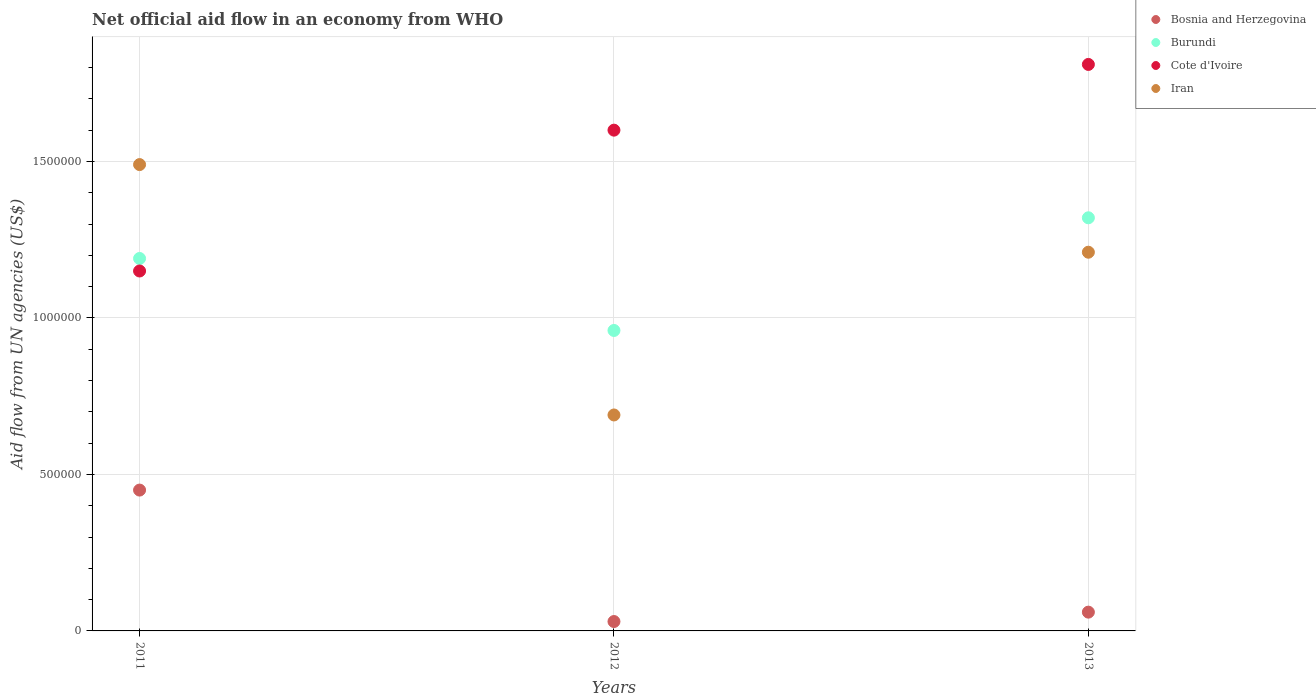Is the number of dotlines equal to the number of legend labels?
Your answer should be very brief. Yes. What is the net official aid flow in Bosnia and Herzegovina in 2012?
Ensure brevity in your answer.  3.00e+04. Across all years, what is the minimum net official aid flow in Cote d'Ivoire?
Provide a succinct answer. 1.15e+06. In which year was the net official aid flow in Burundi maximum?
Give a very brief answer. 2013. In which year was the net official aid flow in Cote d'Ivoire minimum?
Offer a very short reply. 2011. What is the total net official aid flow in Bosnia and Herzegovina in the graph?
Your response must be concise. 5.40e+05. What is the difference between the net official aid flow in Burundi in 2011 and that in 2013?
Offer a very short reply. -1.30e+05. What is the difference between the net official aid flow in Burundi in 2013 and the net official aid flow in Iran in 2012?
Provide a succinct answer. 6.30e+05. What is the average net official aid flow in Burundi per year?
Provide a short and direct response. 1.16e+06. In how many years, is the net official aid flow in Bosnia and Herzegovina greater than 1000000 US$?
Your response must be concise. 0. What is the ratio of the net official aid flow in Burundi in 2011 to that in 2013?
Your response must be concise. 0.9. Is the net official aid flow in Bosnia and Herzegovina in 2011 less than that in 2012?
Keep it short and to the point. No. Is the difference between the net official aid flow in Iran in 2011 and 2012 greater than the difference between the net official aid flow in Burundi in 2011 and 2012?
Your answer should be very brief. Yes. What is the difference between the highest and the second highest net official aid flow in Cote d'Ivoire?
Provide a succinct answer. 2.10e+05. What is the difference between the highest and the lowest net official aid flow in Bosnia and Herzegovina?
Offer a terse response. 4.20e+05. Is it the case that in every year, the sum of the net official aid flow in Burundi and net official aid flow in Cote d'Ivoire  is greater than the net official aid flow in Iran?
Your answer should be compact. Yes. How many years are there in the graph?
Keep it short and to the point. 3. Does the graph contain grids?
Make the answer very short. Yes. What is the title of the graph?
Provide a short and direct response. Net official aid flow in an economy from WHO. What is the label or title of the Y-axis?
Provide a succinct answer. Aid flow from UN agencies (US$). What is the Aid flow from UN agencies (US$) of Burundi in 2011?
Provide a succinct answer. 1.19e+06. What is the Aid flow from UN agencies (US$) in Cote d'Ivoire in 2011?
Provide a short and direct response. 1.15e+06. What is the Aid flow from UN agencies (US$) of Iran in 2011?
Your response must be concise. 1.49e+06. What is the Aid flow from UN agencies (US$) in Burundi in 2012?
Offer a very short reply. 9.60e+05. What is the Aid flow from UN agencies (US$) in Cote d'Ivoire in 2012?
Your answer should be very brief. 1.60e+06. What is the Aid flow from UN agencies (US$) in Iran in 2012?
Offer a very short reply. 6.90e+05. What is the Aid flow from UN agencies (US$) in Burundi in 2013?
Your answer should be very brief. 1.32e+06. What is the Aid flow from UN agencies (US$) of Cote d'Ivoire in 2013?
Your response must be concise. 1.81e+06. What is the Aid flow from UN agencies (US$) of Iran in 2013?
Ensure brevity in your answer.  1.21e+06. Across all years, what is the maximum Aid flow from UN agencies (US$) of Burundi?
Keep it short and to the point. 1.32e+06. Across all years, what is the maximum Aid flow from UN agencies (US$) of Cote d'Ivoire?
Your answer should be compact. 1.81e+06. Across all years, what is the maximum Aid flow from UN agencies (US$) of Iran?
Provide a succinct answer. 1.49e+06. Across all years, what is the minimum Aid flow from UN agencies (US$) in Bosnia and Herzegovina?
Offer a terse response. 3.00e+04. Across all years, what is the minimum Aid flow from UN agencies (US$) of Burundi?
Your answer should be compact. 9.60e+05. Across all years, what is the minimum Aid flow from UN agencies (US$) in Cote d'Ivoire?
Your answer should be compact. 1.15e+06. Across all years, what is the minimum Aid flow from UN agencies (US$) in Iran?
Your response must be concise. 6.90e+05. What is the total Aid flow from UN agencies (US$) of Bosnia and Herzegovina in the graph?
Make the answer very short. 5.40e+05. What is the total Aid flow from UN agencies (US$) of Burundi in the graph?
Your answer should be very brief. 3.47e+06. What is the total Aid flow from UN agencies (US$) of Cote d'Ivoire in the graph?
Ensure brevity in your answer.  4.56e+06. What is the total Aid flow from UN agencies (US$) of Iran in the graph?
Your answer should be compact. 3.39e+06. What is the difference between the Aid flow from UN agencies (US$) of Bosnia and Herzegovina in 2011 and that in 2012?
Your answer should be very brief. 4.20e+05. What is the difference between the Aid flow from UN agencies (US$) in Cote d'Ivoire in 2011 and that in 2012?
Provide a succinct answer. -4.50e+05. What is the difference between the Aid flow from UN agencies (US$) of Bosnia and Herzegovina in 2011 and that in 2013?
Keep it short and to the point. 3.90e+05. What is the difference between the Aid flow from UN agencies (US$) of Cote d'Ivoire in 2011 and that in 2013?
Offer a very short reply. -6.60e+05. What is the difference between the Aid flow from UN agencies (US$) of Bosnia and Herzegovina in 2012 and that in 2013?
Your answer should be very brief. -3.00e+04. What is the difference between the Aid flow from UN agencies (US$) in Burundi in 2012 and that in 2013?
Your response must be concise. -3.60e+05. What is the difference between the Aid flow from UN agencies (US$) of Cote d'Ivoire in 2012 and that in 2013?
Give a very brief answer. -2.10e+05. What is the difference between the Aid flow from UN agencies (US$) in Iran in 2012 and that in 2013?
Keep it short and to the point. -5.20e+05. What is the difference between the Aid flow from UN agencies (US$) of Bosnia and Herzegovina in 2011 and the Aid flow from UN agencies (US$) of Burundi in 2012?
Offer a terse response. -5.10e+05. What is the difference between the Aid flow from UN agencies (US$) of Bosnia and Herzegovina in 2011 and the Aid flow from UN agencies (US$) of Cote d'Ivoire in 2012?
Your response must be concise. -1.15e+06. What is the difference between the Aid flow from UN agencies (US$) of Bosnia and Herzegovina in 2011 and the Aid flow from UN agencies (US$) of Iran in 2012?
Your response must be concise. -2.40e+05. What is the difference between the Aid flow from UN agencies (US$) in Burundi in 2011 and the Aid flow from UN agencies (US$) in Cote d'Ivoire in 2012?
Provide a short and direct response. -4.10e+05. What is the difference between the Aid flow from UN agencies (US$) of Burundi in 2011 and the Aid flow from UN agencies (US$) of Iran in 2012?
Give a very brief answer. 5.00e+05. What is the difference between the Aid flow from UN agencies (US$) in Bosnia and Herzegovina in 2011 and the Aid flow from UN agencies (US$) in Burundi in 2013?
Make the answer very short. -8.70e+05. What is the difference between the Aid flow from UN agencies (US$) of Bosnia and Herzegovina in 2011 and the Aid flow from UN agencies (US$) of Cote d'Ivoire in 2013?
Offer a very short reply. -1.36e+06. What is the difference between the Aid flow from UN agencies (US$) in Bosnia and Herzegovina in 2011 and the Aid flow from UN agencies (US$) in Iran in 2013?
Make the answer very short. -7.60e+05. What is the difference between the Aid flow from UN agencies (US$) in Burundi in 2011 and the Aid flow from UN agencies (US$) in Cote d'Ivoire in 2013?
Your answer should be very brief. -6.20e+05. What is the difference between the Aid flow from UN agencies (US$) of Cote d'Ivoire in 2011 and the Aid flow from UN agencies (US$) of Iran in 2013?
Your answer should be compact. -6.00e+04. What is the difference between the Aid flow from UN agencies (US$) in Bosnia and Herzegovina in 2012 and the Aid flow from UN agencies (US$) in Burundi in 2013?
Give a very brief answer. -1.29e+06. What is the difference between the Aid flow from UN agencies (US$) of Bosnia and Herzegovina in 2012 and the Aid flow from UN agencies (US$) of Cote d'Ivoire in 2013?
Your response must be concise. -1.78e+06. What is the difference between the Aid flow from UN agencies (US$) of Bosnia and Herzegovina in 2012 and the Aid flow from UN agencies (US$) of Iran in 2013?
Give a very brief answer. -1.18e+06. What is the difference between the Aid flow from UN agencies (US$) of Burundi in 2012 and the Aid flow from UN agencies (US$) of Cote d'Ivoire in 2013?
Your answer should be very brief. -8.50e+05. What is the difference between the Aid flow from UN agencies (US$) in Cote d'Ivoire in 2012 and the Aid flow from UN agencies (US$) in Iran in 2013?
Give a very brief answer. 3.90e+05. What is the average Aid flow from UN agencies (US$) of Bosnia and Herzegovina per year?
Make the answer very short. 1.80e+05. What is the average Aid flow from UN agencies (US$) of Burundi per year?
Provide a short and direct response. 1.16e+06. What is the average Aid flow from UN agencies (US$) of Cote d'Ivoire per year?
Provide a succinct answer. 1.52e+06. What is the average Aid flow from UN agencies (US$) in Iran per year?
Offer a terse response. 1.13e+06. In the year 2011, what is the difference between the Aid flow from UN agencies (US$) in Bosnia and Herzegovina and Aid flow from UN agencies (US$) in Burundi?
Provide a succinct answer. -7.40e+05. In the year 2011, what is the difference between the Aid flow from UN agencies (US$) of Bosnia and Herzegovina and Aid flow from UN agencies (US$) of Cote d'Ivoire?
Keep it short and to the point. -7.00e+05. In the year 2011, what is the difference between the Aid flow from UN agencies (US$) of Bosnia and Herzegovina and Aid flow from UN agencies (US$) of Iran?
Offer a terse response. -1.04e+06. In the year 2011, what is the difference between the Aid flow from UN agencies (US$) in Burundi and Aid flow from UN agencies (US$) in Cote d'Ivoire?
Your answer should be very brief. 4.00e+04. In the year 2012, what is the difference between the Aid flow from UN agencies (US$) in Bosnia and Herzegovina and Aid flow from UN agencies (US$) in Burundi?
Offer a terse response. -9.30e+05. In the year 2012, what is the difference between the Aid flow from UN agencies (US$) in Bosnia and Herzegovina and Aid flow from UN agencies (US$) in Cote d'Ivoire?
Offer a terse response. -1.57e+06. In the year 2012, what is the difference between the Aid flow from UN agencies (US$) of Bosnia and Herzegovina and Aid flow from UN agencies (US$) of Iran?
Your answer should be compact. -6.60e+05. In the year 2012, what is the difference between the Aid flow from UN agencies (US$) of Burundi and Aid flow from UN agencies (US$) of Cote d'Ivoire?
Provide a short and direct response. -6.40e+05. In the year 2012, what is the difference between the Aid flow from UN agencies (US$) of Cote d'Ivoire and Aid flow from UN agencies (US$) of Iran?
Ensure brevity in your answer.  9.10e+05. In the year 2013, what is the difference between the Aid flow from UN agencies (US$) of Bosnia and Herzegovina and Aid flow from UN agencies (US$) of Burundi?
Keep it short and to the point. -1.26e+06. In the year 2013, what is the difference between the Aid flow from UN agencies (US$) in Bosnia and Herzegovina and Aid flow from UN agencies (US$) in Cote d'Ivoire?
Ensure brevity in your answer.  -1.75e+06. In the year 2013, what is the difference between the Aid flow from UN agencies (US$) in Bosnia and Herzegovina and Aid flow from UN agencies (US$) in Iran?
Your answer should be compact. -1.15e+06. In the year 2013, what is the difference between the Aid flow from UN agencies (US$) in Burundi and Aid flow from UN agencies (US$) in Cote d'Ivoire?
Offer a terse response. -4.90e+05. In the year 2013, what is the difference between the Aid flow from UN agencies (US$) in Burundi and Aid flow from UN agencies (US$) in Iran?
Provide a succinct answer. 1.10e+05. What is the ratio of the Aid flow from UN agencies (US$) of Bosnia and Herzegovina in 2011 to that in 2012?
Your answer should be very brief. 15. What is the ratio of the Aid flow from UN agencies (US$) of Burundi in 2011 to that in 2012?
Provide a succinct answer. 1.24. What is the ratio of the Aid flow from UN agencies (US$) in Cote d'Ivoire in 2011 to that in 2012?
Keep it short and to the point. 0.72. What is the ratio of the Aid flow from UN agencies (US$) in Iran in 2011 to that in 2012?
Make the answer very short. 2.16. What is the ratio of the Aid flow from UN agencies (US$) in Burundi in 2011 to that in 2013?
Offer a terse response. 0.9. What is the ratio of the Aid flow from UN agencies (US$) of Cote d'Ivoire in 2011 to that in 2013?
Provide a short and direct response. 0.64. What is the ratio of the Aid flow from UN agencies (US$) in Iran in 2011 to that in 2013?
Your answer should be compact. 1.23. What is the ratio of the Aid flow from UN agencies (US$) of Burundi in 2012 to that in 2013?
Ensure brevity in your answer.  0.73. What is the ratio of the Aid flow from UN agencies (US$) in Cote d'Ivoire in 2012 to that in 2013?
Your response must be concise. 0.88. What is the ratio of the Aid flow from UN agencies (US$) of Iran in 2012 to that in 2013?
Provide a succinct answer. 0.57. What is the difference between the highest and the second highest Aid flow from UN agencies (US$) in Burundi?
Ensure brevity in your answer.  1.30e+05. What is the difference between the highest and the second highest Aid flow from UN agencies (US$) in Iran?
Your answer should be compact. 2.80e+05. What is the difference between the highest and the lowest Aid flow from UN agencies (US$) in Cote d'Ivoire?
Offer a very short reply. 6.60e+05. What is the difference between the highest and the lowest Aid flow from UN agencies (US$) of Iran?
Your answer should be very brief. 8.00e+05. 